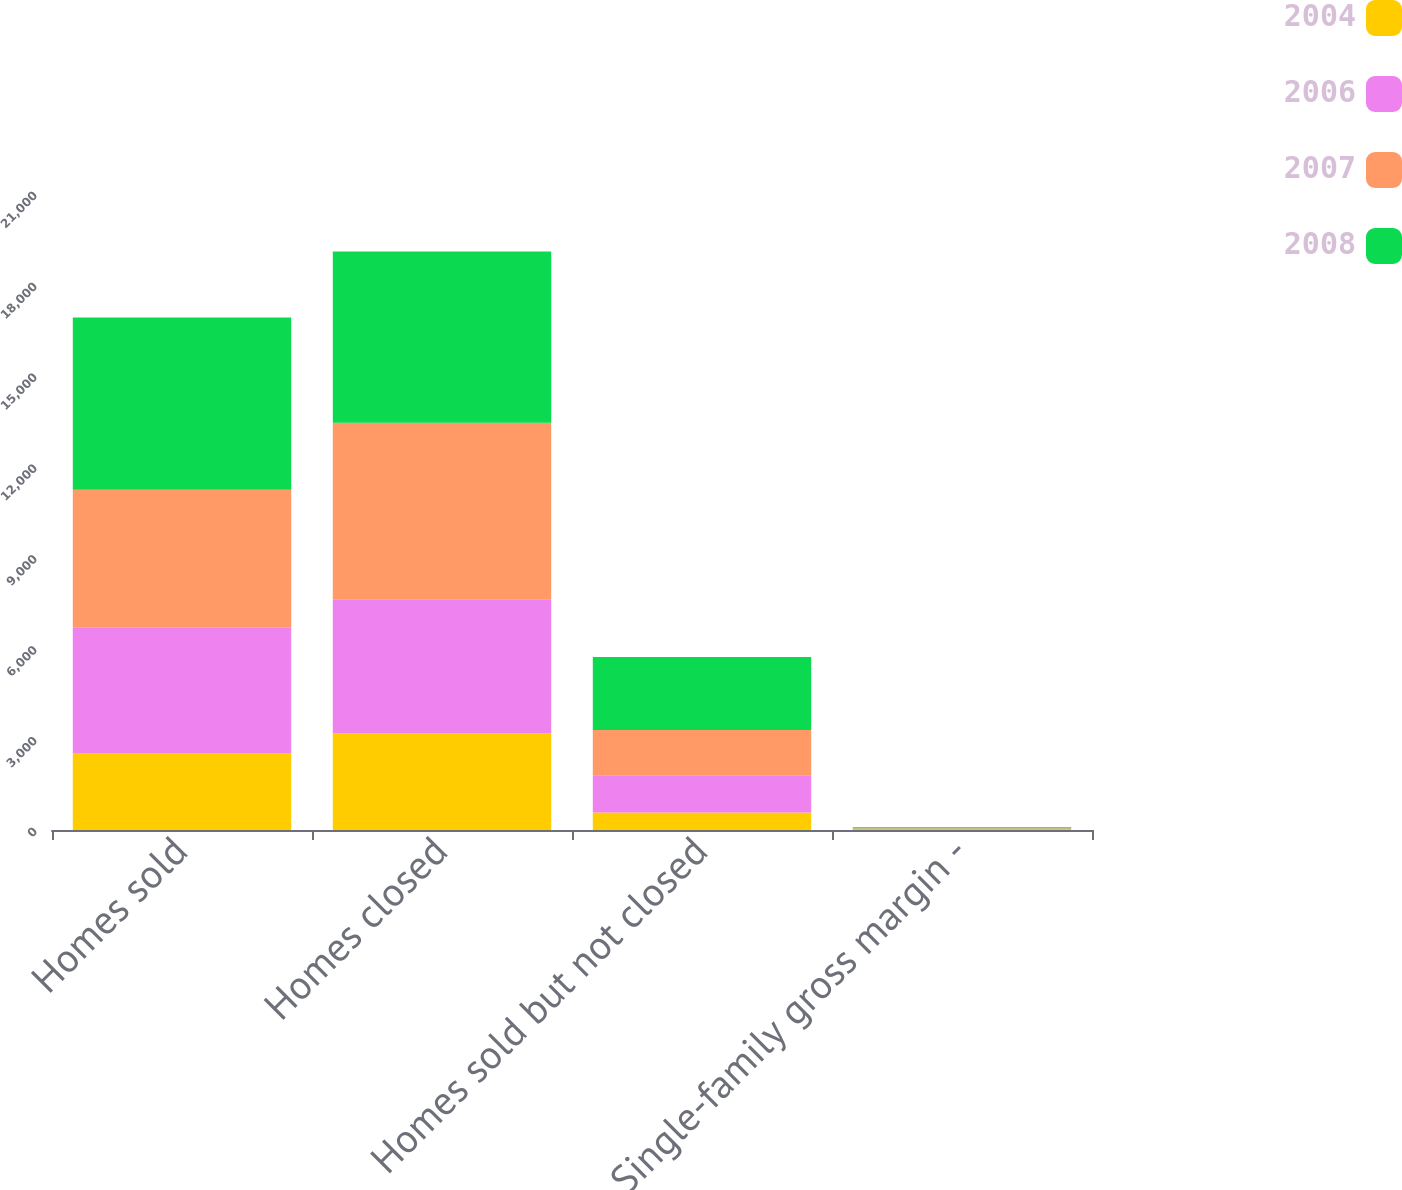Convert chart. <chart><loc_0><loc_0><loc_500><loc_500><stacked_bar_chart><ecel><fcel>Homes sold<fcel>Homes closed<fcel>Homes sold but not closed<fcel>Single-family gross margin -<nl><fcel>2004<fcel>2545<fcel>3188<fcel>581<fcel>11.5<nl><fcel>2006<fcel>4152<fcel>4427<fcel>1224<fcel>21.2<nl><fcel>2007<fcel>4541<fcel>5836<fcel>1499<fcel>27.6<nl><fcel>2008<fcel>5685<fcel>5647<fcel>2410<fcel>32.8<nl></chart> 